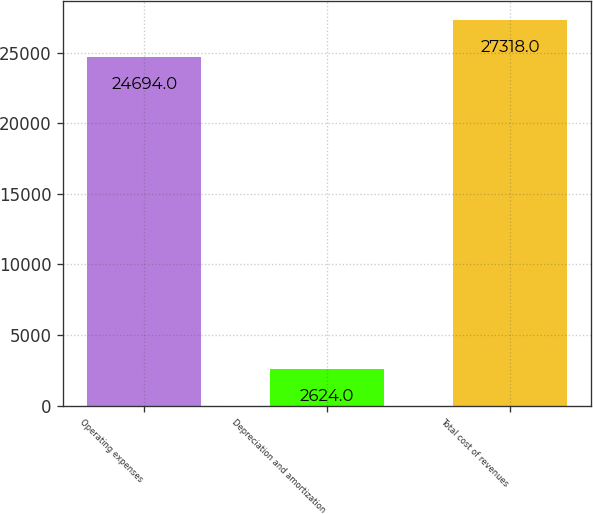Convert chart to OTSL. <chart><loc_0><loc_0><loc_500><loc_500><bar_chart><fcel>Operating expenses<fcel>Depreciation and amortization<fcel>Total cost of revenues<nl><fcel>24694<fcel>2624<fcel>27318<nl></chart> 